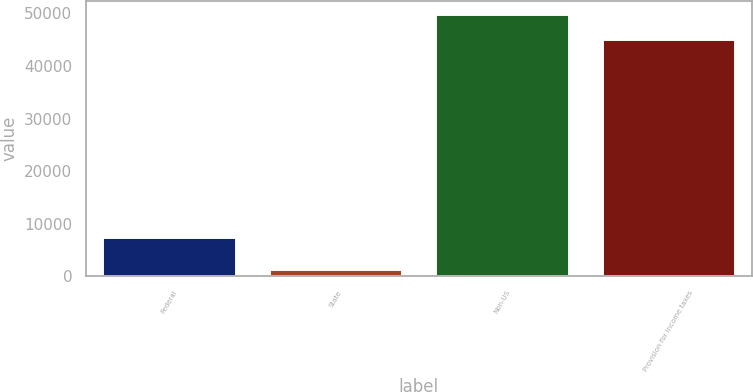<chart> <loc_0><loc_0><loc_500><loc_500><bar_chart><fcel>Federal<fcel>State<fcel>Non-US<fcel>Provision for income taxes<nl><fcel>7507<fcel>1370<fcel>49868.1<fcel>45183<nl></chart> 